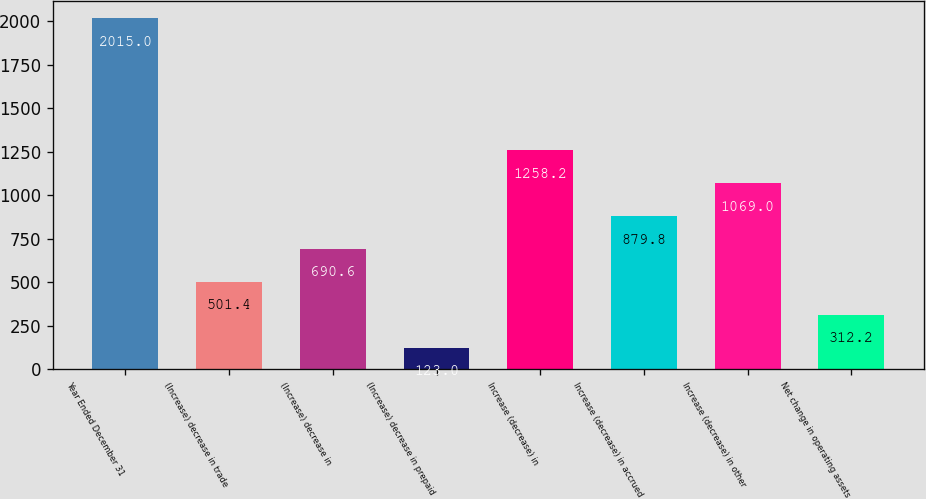Convert chart. <chart><loc_0><loc_0><loc_500><loc_500><bar_chart><fcel>Year Ended December 31<fcel>(Increase) decrease in trade<fcel>(Increase) decrease in<fcel>(Increase) decrease in prepaid<fcel>Increase (decrease) in<fcel>Increase (decrease) in accrued<fcel>Increase (decrease) in other<fcel>Net change in operating assets<nl><fcel>2015<fcel>501.4<fcel>690.6<fcel>123<fcel>1258.2<fcel>879.8<fcel>1069<fcel>312.2<nl></chart> 